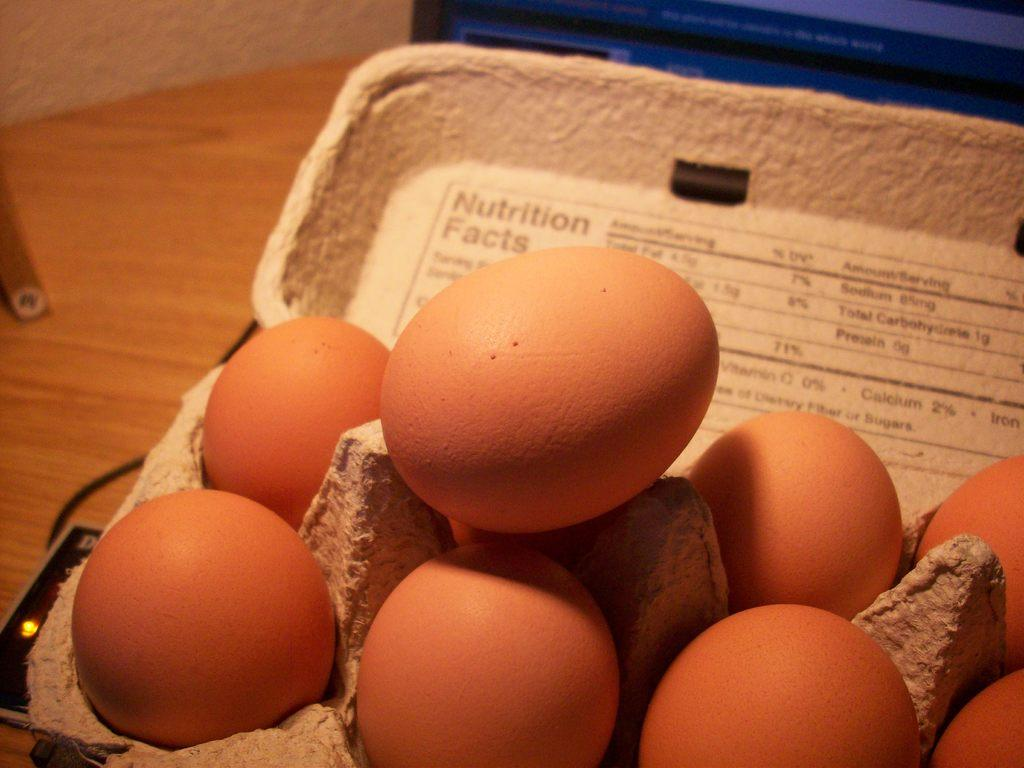What is on the tray that is visible in the image? There is a tray of eggs in the image. What else can be seen on the left side of the image? There is a wire on the left side of the image. Where is the dock located in the image? There is no dock present in the image. What type of crown can be seen on the tray of eggs? There is no crown present on the tray of eggs; it only contains eggs. 